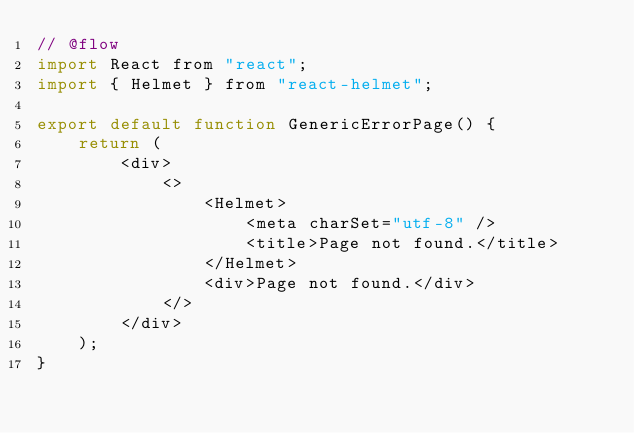<code> <loc_0><loc_0><loc_500><loc_500><_JavaScript_>// @flow
import React from "react";
import { Helmet } from "react-helmet";

export default function GenericErrorPage() {
    return (
        <div>
            <>
                <Helmet>
                    <meta charSet="utf-8" />
                    <title>Page not found.</title>
                </Helmet>
                <div>Page not found.</div>
            </>
        </div>
    );
}
</code> 